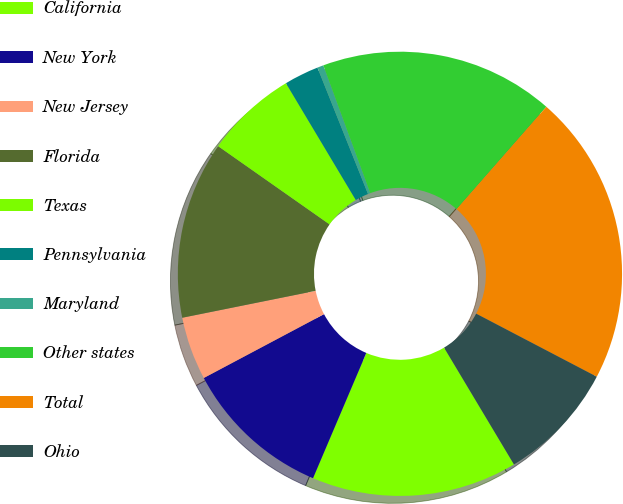Convert chart to OTSL. <chart><loc_0><loc_0><loc_500><loc_500><pie_chart><fcel>California<fcel>New York<fcel>New Jersey<fcel>Florida<fcel>Texas<fcel>Pennsylvania<fcel>Maryland<fcel>Other states<fcel>Total<fcel>Ohio<nl><fcel>14.98%<fcel>10.83%<fcel>4.6%<fcel>12.91%<fcel>6.68%<fcel>2.52%<fcel>0.45%<fcel>17.06%<fcel>21.21%<fcel>8.75%<nl></chart> 